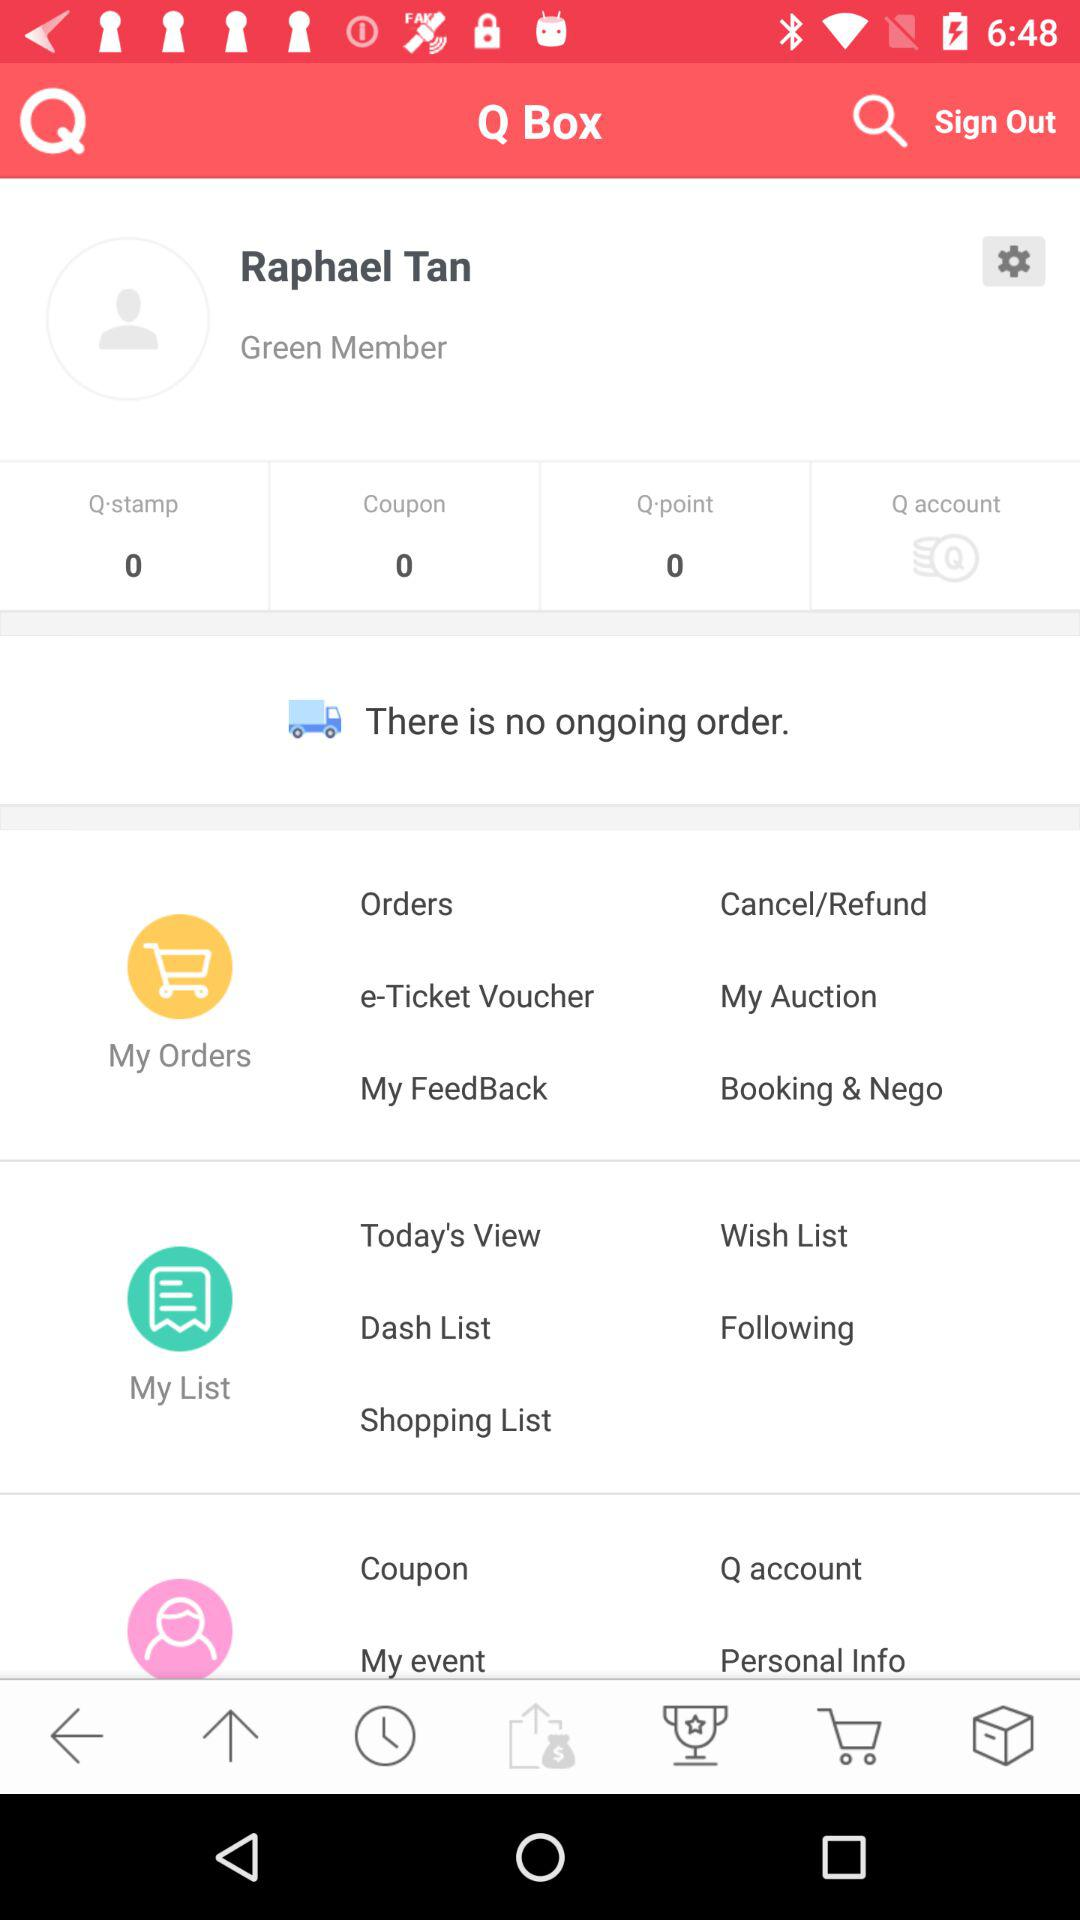How many points are there? There are 0 points. 